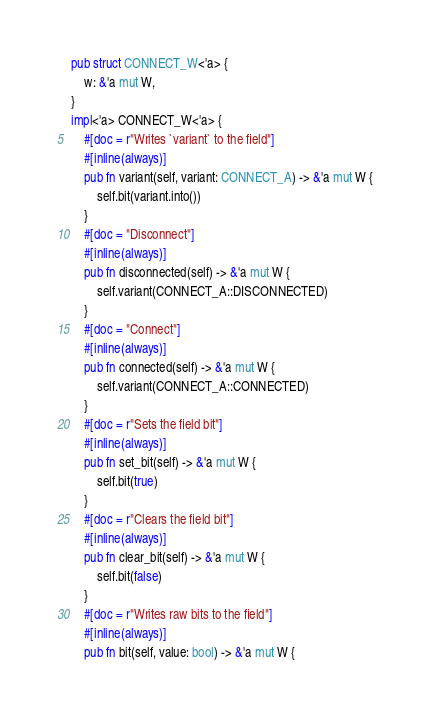Convert code to text. <code><loc_0><loc_0><loc_500><loc_500><_Rust_>pub struct CONNECT_W<'a> {
    w: &'a mut W,
}
impl<'a> CONNECT_W<'a> {
    #[doc = r"Writes `variant` to the field"]
    #[inline(always)]
    pub fn variant(self, variant: CONNECT_A) -> &'a mut W {
        self.bit(variant.into())
    }
    #[doc = "Disconnect"]
    #[inline(always)]
    pub fn disconnected(self) -> &'a mut W {
        self.variant(CONNECT_A::DISCONNECTED)
    }
    #[doc = "Connect"]
    #[inline(always)]
    pub fn connected(self) -> &'a mut W {
        self.variant(CONNECT_A::CONNECTED)
    }
    #[doc = r"Sets the field bit"]
    #[inline(always)]
    pub fn set_bit(self) -> &'a mut W {
        self.bit(true)
    }
    #[doc = r"Clears the field bit"]
    #[inline(always)]
    pub fn clear_bit(self) -> &'a mut W {
        self.bit(false)
    }
    #[doc = r"Writes raw bits to the field"]
    #[inline(always)]
    pub fn bit(self, value: bool) -> &'a mut W {</code> 